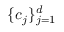Convert formula to latex. <formula><loc_0><loc_0><loc_500><loc_500>\{ c _ { j } \} _ { j = 1 } ^ { d }</formula> 